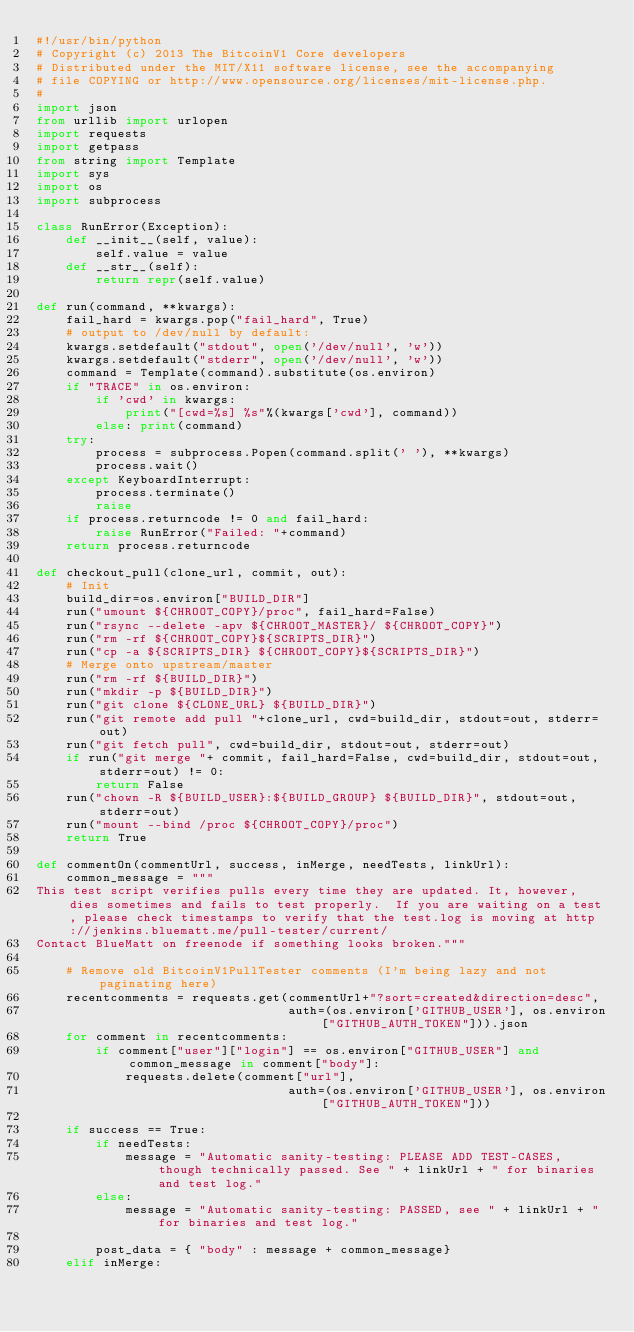<code> <loc_0><loc_0><loc_500><loc_500><_Python_>#!/usr/bin/python
# Copyright (c) 2013 The BitcoinV1 Core developers
# Distributed under the MIT/X11 software license, see the accompanying
# file COPYING or http://www.opensource.org/licenses/mit-license.php.
#
import json
from urllib import urlopen
import requests
import getpass
from string import Template
import sys
import os
import subprocess

class RunError(Exception):
    def __init__(self, value):
        self.value = value
    def __str__(self):
        return repr(self.value)

def run(command, **kwargs):
    fail_hard = kwargs.pop("fail_hard", True)
    # output to /dev/null by default:
    kwargs.setdefault("stdout", open('/dev/null', 'w'))
    kwargs.setdefault("stderr", open('/dev/null', 'w'))
    command = Template(command).substitute(os.environ)
    if "TRACE" in os.environ:
        if 'cwd' in kwargs:
            print("[cwd=%s] %s"%(kwargs['cwd'], command))
        else: print(command)
    try:
        process = subprocess.Popen(command.split(' '), **kwargs)
        process.wait()
    except KeyboardInterrupt:
        process.terminate()
        raise
    if process.returncode != 0 and fail_hard:
        raise RunError("Failed: "+command)
    return process.returncode

def checkout_pull(clone_url, commit, out):
    # Init
    build_dir=os.environ["BUILD_DIR"]
    run("umount ${CHROOT_COPY}/proc", fail_hard=False)
    run("rsync --delete -apv ${CHROOT_MASTER}/ ${CHROOT_COPY}")
    run("rm -rf ${CHROOT_COPY}${SCRIPTS_DIR}")
    run("cp -a ${SCRIPTS_DIR} ${CHROOT_COPY}${SCRIPTS_DIR}")
    # Merge onto upstream/master
    run("rm -rf ${BUILD_DIR}")
    run("mkdir -p ${BUILD_DIR}")
    run("git clone ${CLONE_URL} ${BUILD_DIR}")
    run("git remote add pull "+clone_url, cwd=build_dir, stdout=out, stderr=out)
    run("git fetch pull", cwd=build_dir, stdout=out, stderr=out)
    if run("git merge "+ commit, fail_hard=False, cwd=build_dir, stdout=out, stderr=out) != 0:
        return False
    run("chown -R ${BUILD_USER}:${BUILD_GROUP} ${BUILD_DIR}", stdout=out, stderr=out)
    run("mount --bind /proc ${CHROOT_COPY}/proc")
    return True

def commentOn(commentUrl, success, inMerge, needTests, linkUrl):
    common_message = """
This test script verifies pulls every time they are updated. It, however, dies sometimes and fails to test properly.  If you are waiting on a test, please check timestamps to verify that the test.log is moving at http://jenkins.bluematt.me/pull-tester/current/
Contact BlueMatt on freenode if something looks broken."""

    # Remove old BitcoinV1PullTester comments (I'm being lazy and not paginating here)
    recentcomments = requests.get(commentUrl+"?sort=created&direction=desc",
                                  auth=(os.environ['GITHUB_USER'], os.environ["GITHUB_AUTH_TOKEN"])).json
    for comment in recentcomments:
        if comment["user"]["login"] == os.environ["GITHUB_USER"] and common_message in comment["body"]:
            requests.delete(comment["url"],
                                  auth=(os.environ['GITHUB_USER'], os.environ["GITHUB_AUTH_TOKEN"]))

    if success == True:
        if needTests:
            message = "Automatic sanity-testing: PLEASE ADD TEST-CASES, though technically passed. See " + linkUrl + " for binaries and test log."
        else:
            message = "Automatic sanity-testing: PASSED, see " + linkUrl + " for binaries and test log."

        post_data = { "body" : message + common_message}
    elif inMerge:</code> 